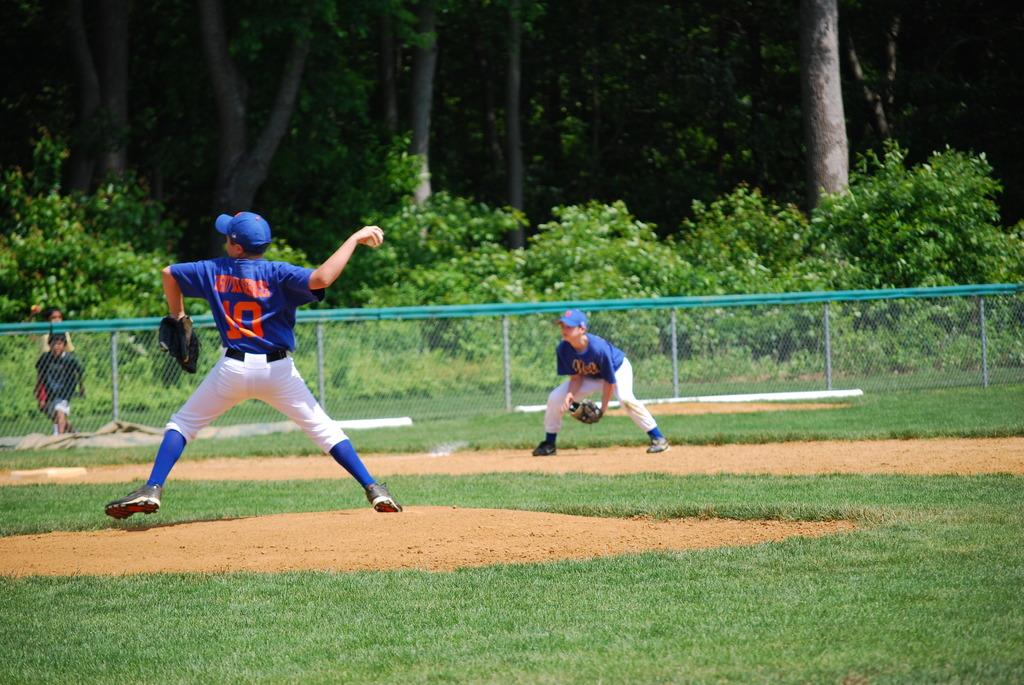<image>
Create a compact narrative representing the image presented. a sportsman with a number 10 on his shirt throws a ball. 